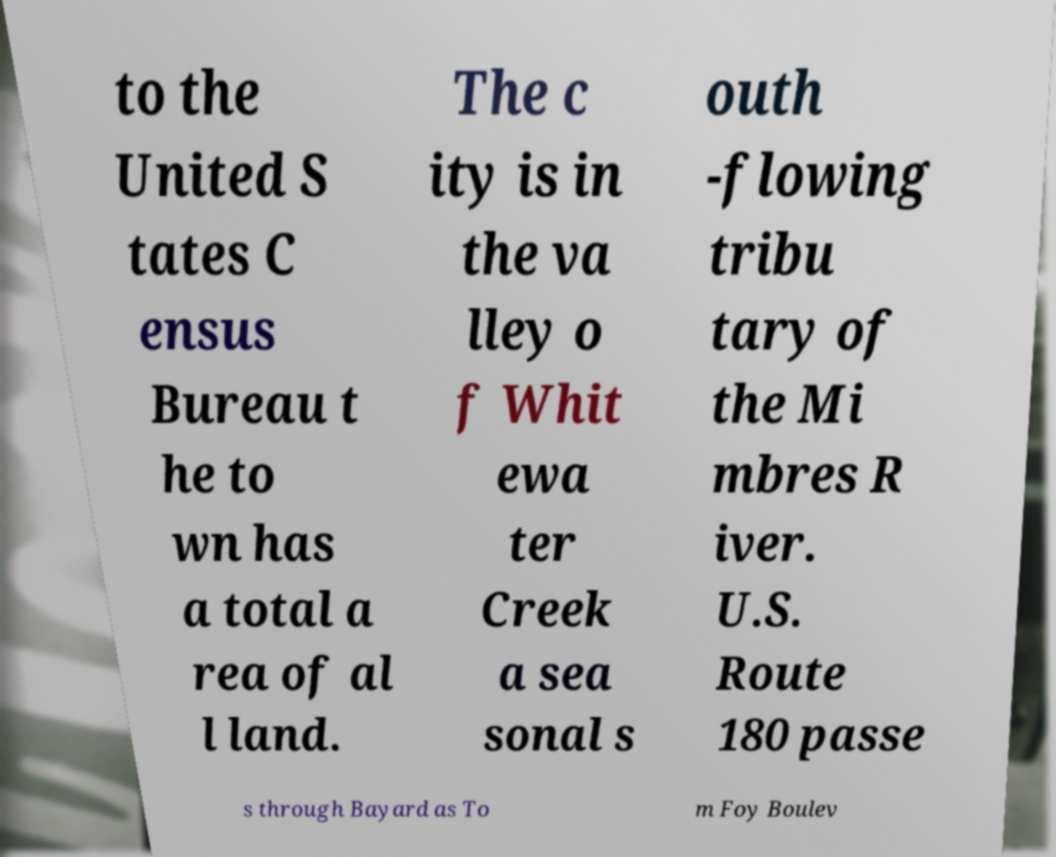Please identify and transcribe the text found in this image. to the United S tates C ensus Bureau t he to wn has a total a rea of al l land. The c ity is in the va lley o f Whit ewa ter Creek a sea sonal s outh -flowing tribu tary of the Mi mbres R iver. U.S. Route 180 passe s through Bayard as To m Foy Boulev 